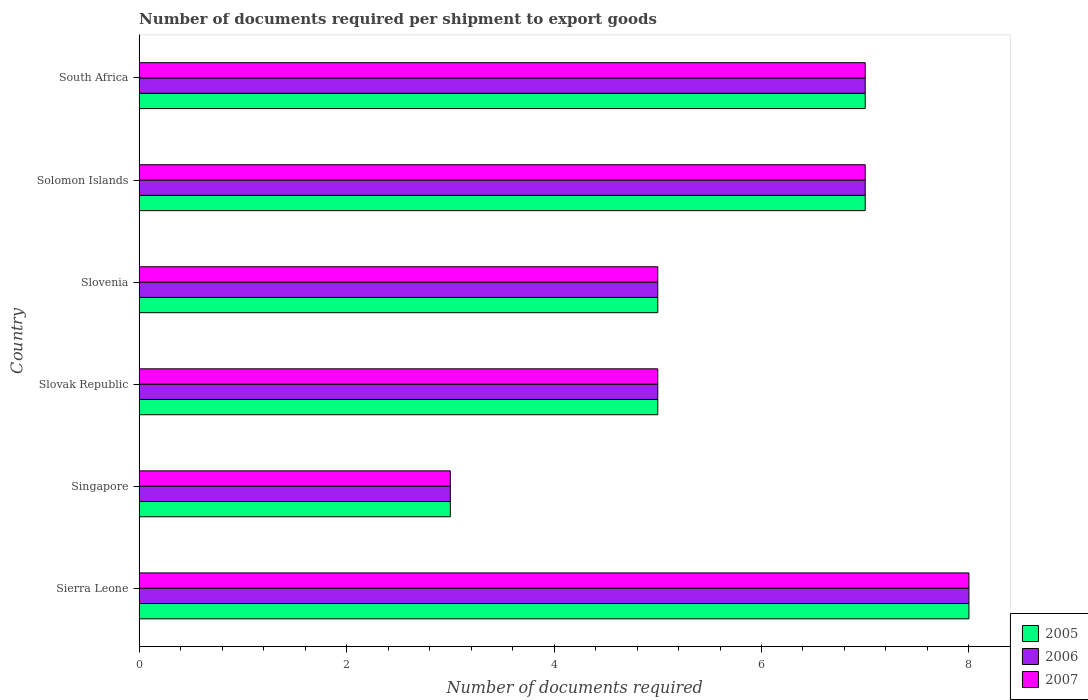How many bars are there on the 6th tick from the top?
Provide a succinct answer. 3. What is the label of the 5th group of bars from the top?
Ensure brevity in your answer.  Singapore. What is the number of documents required per shipment to export goods in 2006 in Solomon Islands?
Your answer should be very brief. 7. In which country was the number of documents required per shipment to export goods in 2007 maximum?
Make the answer very short. Sierra Leone. In which country was the number of documents required per shipment to export goods in 2005 minimum?
Provide a short and direct response. Singapore. What is the average number of documents required per shipment to export goods in 2007 per country?
Your answer should be compact. 5.83. What is the ratio of the number of documents required per shipment to export goods in 2006 in Singapore to that in Solomon Islands?
Offer a terse response. 0.43. Is the difference between the number of documents required per shipment to export goods in 2007 in Singapore and Solomon Islands greater than the difference between the number of documents required per shipment to export goods in 2005 in Singapore and Solomon Islands?
Your answer should be very brief. No. What is the difference between the highest and the second highest number of documents required per shipment to export goods in 2007?
Keep it short and to the point. 1. What is the difference between the highest and the lowest number of documents required per shipment to export goods in 2007?
Offer a terse response. 5. In how many countries, is the number of documents required per shipment to export goods in 2007 greater than the average number of documents required per shipment to export goods in 2007 taken over all countries?
Offer a very short reply. 3. Is it the case that in every country, the sum of the number of documents required per shipment to export goods in 2006 and number of documents required per shipment to export goods in 2007 is greater than the number of documents required per shipment to export goods in 2005?
Offer a terse response. Yes. Are all the bars in the graph horizontal?
Offer a terse response. Yes. How many countries are there in the graph?
Your response must be concise. 6. Does the graph contain any zero values?
Offer a terse response. No. Where does the legend appear in the graph?
Provide a short and direct response. Bottom right. How are the legend labels stacked?
Your answer should be compact. Vertical. What is the title of the graph?
Offer a very short reply. Number of documents required per shipment to export goods. Does "1996" appear as one of the legend labels in the graph?
Provide a short and direct response. No. What is the label or title of the X-axis?
Ensure brevity in your answer.  Number of documents required. What is the Number of documents required in 2005 in Sierra Leone?
Offer a very short reply. 8. What is the Number of documents required of 2006 in Sierra Leone?
Give a very brief answer. 8. What is the Number of documents required of 2005 in Singapore?
Offer a terse response. 3. What is the Number of documents required in 2005 in Slovak Republic?
Provide a short and direct response. 5. What is the Number of documents required of 2006 in Slovak Republic?
Your answer should be very brief. 5. What is the Number of documents required of 2006 in Slovenia?
Your answer should be compact. 5. What is the Number of documents required in 2007 in Slovenia?
Provide a succinct answer. 5. What is the Number of documents required in 2006 in Solomon Islands?
Keep it short and to the point. 7. What is the Number of documents required of 2007 in Solomon Islands?
Offer a terse response. 7. What is the Number of documents required of 2006 in South Africa?
Ensure brevity in your answer.  7. Across all countries, what is the maximum Number of documents required in 2007?
Your answer should be very brief. 8. Across all countries, what is the minimum Number of documents required in 2006?
Make the answer very short. 3. Across all countries, what is the minimum Number of documents required in 2007?
Your answer should be very brief. 3. What is the total Number of documents required in 2005 in the graph?
Give a very brief answer. 35. What is the total Number of documents required in 2006 in the graph?
Offer a very short reply. 35. What is the difference between the Number of documents required of 2006 in Sierra Leone and that in Singapore?
Your answer should be very brief. 5. What is the difference between the Number of documents required in 2007 in Sierra Leone and that in Singapore?
Provide a short and direct response. 5. What is the difference between the Number of documents required of 2005 in Sierra Leone and that in Slovak Republic?
Provide a short and direct response. 3. What is the difference between the Number of documents required in 2007 in Sierra Leone and that in Slovak Republic?
Make the answer very short. 3. What is the difference between the Number of documents required of 2005 in Sierra Leone and that in Slovenia?
Provide a short and direct response. 3. What is the difference between the Number of documents required in 2005 in Sierra Leone and that in Solomon Islands?
Give a very brief answer. 1. What is the difference between the Number of documents required of 2007 in Sierra Leone and that in Solomon Islands?
Provide a succinct answer. 1. What is the difference between the Number of documents required of 2005 in Sierra Leone and that in South Africa?
Offer a terse response. 1. What is the difference between the Number of documents required of 2005 in Singapore and that in Slovak Republic?
Give a very brief answer. -2. What is the difference between the Number of documents required in 2005 in Singapore and that in Slovenia?
Ensure brevity in your answer.  -2. What is the difference between the Number of documents required of 2006 in Singapore and that in Solomon Islands?
Give a very brief answer. -4. What is the difference between the Number of documents required of 2007 in Singapore and that in Solomon Islands?
Keep it short and to the point. -4. What is the difference between the Number of documents required of 2005 in Singapore and that in South Africa?
Offer a very short reply. -4. What is the difference between the Number of documents required in 2006 in Singapore and that in South Africa?
Your answer should be very brief. -4. What is the difference between the Number of documents required in 2005 in Slovak Republic and that in Slovenia?
Offer a terse response. 0. What is the difference between the Number of documents required of 2006 in Slovak Republic and that in Slovenia?
Ensure brevity in your answer.  0. What is the difference between the Number of documents required of 2007 in Slovak Republic and that in Slovenia?
Make the answer very short. 0. What is the difference between the Number of documents required of 2006 in Slovak Republic and that in Solomon Islands?
Your response must be concise. -2. What is the difference between the Number of documents required in 2007 in Slovak Republic and that in Solomon Islands?
Offer a very short reply. -2. What is the difference between the Number of documents required in 2006 in Slovenia and that in South Africa?
Make the answer very short. -2. What is the difference between the Number of documents required of 2007 in Slovenia and that in South Africa?
Your answer should be compact. -2. What is the difference between the Number of documents required in 2005 in Solomon Islands and that in South Africa?
Your answer should be compact. 0. What is the difference between the Number of documents required in 2007 in Solomon Islands and that in South Africa?
Your response must be concise. 0. What is the difference between the Number of documents required in 2005 in Sierra Leone and the Number of documents required in 2007 in Singapore?
Ensure brevity in your answer.  5. What is the difference between the Number of documents required in 2006 in Sierra Leone and the Number of documents required in 2007 in Singapore?
Make the answer very short. 5. What is the difference between the Number of documents required in 2005 in Sierra Leone and the Number of documents required in 2006 in Slovak Republic?
Your answer should be very brief. 3. What is the difference between the Number of documents required in 2006 in Sierra Leone and the Number of documents required in 2007 in Slovak Republic?
Your response must be concise. 3. What is the difference between the Number of documents required in 2005 in Sierra Leone and the Number of documents required in 2006 in Slovenia?
Make the answer very short. 3. What is the difference between the Number of documents required in 2005 in Sierra Leone and the Number of documents required in 2007 in Slovenia?
Give a very brief answer. 3. What is the difference between the Number of documents required of 2006 in Sierra Leone and the Number of documents required of 2007 in Slovenia?
Offer a very short reply. 3. What is the difference between the Number of documents required of 2005 in Sierra Leone and the Number of documents required of 2006 in Solomon Islands?
Give a very brief answer. 1. What is the difference between the Number of documents required in 2005 in Sierra Leone and the Number of documents required in 2007 in South Africa?
Keep it short and to the point. 1. What is the difference between the Number of documents required in 2006 in Sierra Leone and the Number of documents required in 2007 in South Africa?
Offer a very short reply. 1. What is the difference between the Number of documents required of 2005 in Singapore and the Number of documents required of 2006 in Slovak Republic?
Provide a short and direct response. -2. What is the difference between the Number of documents required in 2005 in Singapore and the Number of documents required in 2007 in Slovak Republic?
Your response must be concise. -2. What is the difference between the Number of documents required in 2006 in Singapore and the Number of documents required in 2007 in Slovenia?
Offer a terse response. -2. What is the difference between the Number of documents required of 2005 in Singapore and the Number of documents required of 2007 in Solomon Islands?
Your answer should be very brief. -4. What is the difference between the Number of documents required of 2005 in Slovak Republic and the Number of documents required of 2007 in Slovenia?
Ensure brevity in your answer.  0. What is the difference between the Number of documents required in 2005 in Slovak Republic and the Number of documents required in 2007 in Solomon Islands?
Provide a succinct answer. -2. What is the difference between the Number of documents required in 2006 in Slovak Republic and the Number of documents required in 2007 in Solomon Islands?
Offer a very short reply. -2. What is the difference between the Number of documents required of 2005 in Slovak Republic and the Number of documents required of 2007 in South Africa?
Your answer should be very brief. -2. What is the difference between the Number of documents required of 2005 in Slovenia and the Number of documents required of 2006 in Solomon Islands?
Your response must be concise. -2. What is the difference between the Number of documents required in 2006 in Slovenia and the Number of documents required in 2007 in Solomon Islands?
Provide a short and direct response. -2. What is the difference between the Number of documents required of 2005 in Slovenia and the Number of documents required of 2007 in South Africa?
Your response must be concise. -2. What is the difference between the Number of documents required in 2006 in Slovenia and the Number of documents required in 2007 in South Africa?
Your response must be concise. -2. What is the difference between the Number of documents required in 2005 in Solomon Islands and the Number of documents required in 2006 in South Africa?
Give a very brief answer. 0. What is the average Number of documents required in 2005 per country?
Make the answer very short. 5.83. What is the average Number of documents required of 2006 per country?
Your answer should be compact. 5.83. What is the average Number of documents required in 2007 per country?
Make the answer very short. 5.83. What is the difference between the Number of documents required in 2005 and Number of documents required in 2007 in Singapore?
Offer a terse response. 0. What is the difference between the Number of documents required of 2006 and Number of documents required of 2007 in Singapore?
Offer a terse response. 0. What is the difference between the Number of documents required of 2005 and Number of documents required of 2006 in Slovenia?
Make the answer very short. 0. What is the difference between the Number of documents required in 2005 and Number of documents required in 2007 in Slovenia?
Give a very brief answer. 0. What is the difference between the Number of documents required of 2006 and Number of documents required of 2007 in Slovenia?
Make the answer very short. 0. What is the ratio of the Number of documents required of 2005 in Sierra Leone to that in Singapore?
Your response must be concise. 2.67. What is the ratio of the Number of documents required in 2006 in Sierra Leone to that in Singapore?
Your answer should be very brief. 2.67. What is the ratio of the Number of documents required in 2007 in Sierra Leone to that in Singapore?
Provide a short and direct response. 2.67. What is the ratio of the Number of documents required of 2006 in Sierra Leone to that in South Africa?
Ensure brevity in your answer.  1.14. What is the ratio of the Number of documents required of 2007 in Sierra Leone to that in South Africa?
Offer a terse response. 1.14. What is the ratio of the Number of documents required in 2005 in Singapore to that in Slovak Republic?
Your answer should be very brief. 0.6. What is the ratio of the Number of documents required of 2006 in Singapore to that in Slovak Republic?
Provide a short and direct response. 0.6. What is the ratio of the Number of documents required of 2007 in Singapore to that in Slovak Republic?
Ensure brevity in your answer.  0.6. What is the ratio of the Number of documents required in 2006 in Singapore to that in Slovenia?
Provide a short and direct response. 0.6. What is the ratio of the Number of documents required of 2007 in Singapore to that in Slovenia?
Provide a succinct answer. 0.6. What is the ratio of the Number of documents required in 2005 in Singapore to that in Solomon Islands?
Offer a terse response. 0.43. What is the ratio of the Number of documents required in 2006 in Singapore to that in Solomon Islands?
Keep it short and to the point. 0.43. What is the ratio of the Number of documents required in 2007 in Singapore to that in Solomon Islands?
Provide a short and direct response. 0.43. What is the ratio of the Number of documents required of 2005 in Singapore to that in South Africa?
Provide a short and direct response. 0.43. What is the ratio of the Number of documents required of 2006 in Singapore to that in South Africa?
Your answer should be very brief. 0.43. What is the ratio of the Number of documents required in 2007 in Singapore to that in South Africa?
Make the answer very short. 0.43. What is the ratio of the Number of documents required in 2007 in Slovak Republic to that in Slovenia?
Provide a short and direct response. 1. What is the ratio of the Number of documents required in 2006 in Slovak Republic to that in Solomon Islands?
Provide a succinct answer. 0.71. What is the ratio of the Number of documents required of 2007 in Slovak Republic to that in South Africa?
Keep it short and to the point. 0.71. What is the ratio of the Number of documents required in 2006 in Slovenia to that in Solomon Islands?
Provide a succinct answer. 0.71. What is the ratio of the Number of documents required of 2006 in Slovenia to that in South Africa?
Offer a terse response. 0.71. What is the ratio of the Number of documents required of 2005 in Solomon Islands to that in South Africa?
Give a very brief answer. 1. What is the difference between the highest and the second highest Number of documents required of 2005?
Keep it short and to the point. 1. What is the difference between the highest and the second highest Number of documents required in 2006?
Your response must be concise. 1. What is the difference between the highest and the lowest Number of documents required in 2005?
Ensure brevity in your answer.  5. What is the difference between the highest and the lowest Number of documents required of 2006?
Provide a short and direct response. 5. What is the difference between the highest and the lowest Number of documents required of 2007?
Keep it short and to the point. 5. 